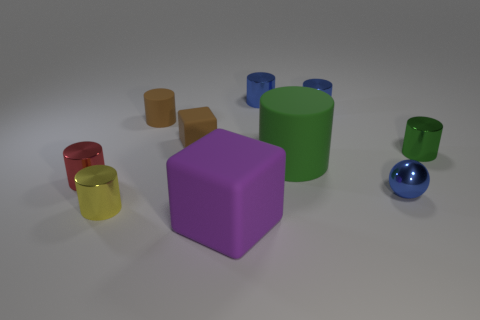How many objects in the image are cylindrical? There are five cylindrical objects in the image, varying in size and color. 